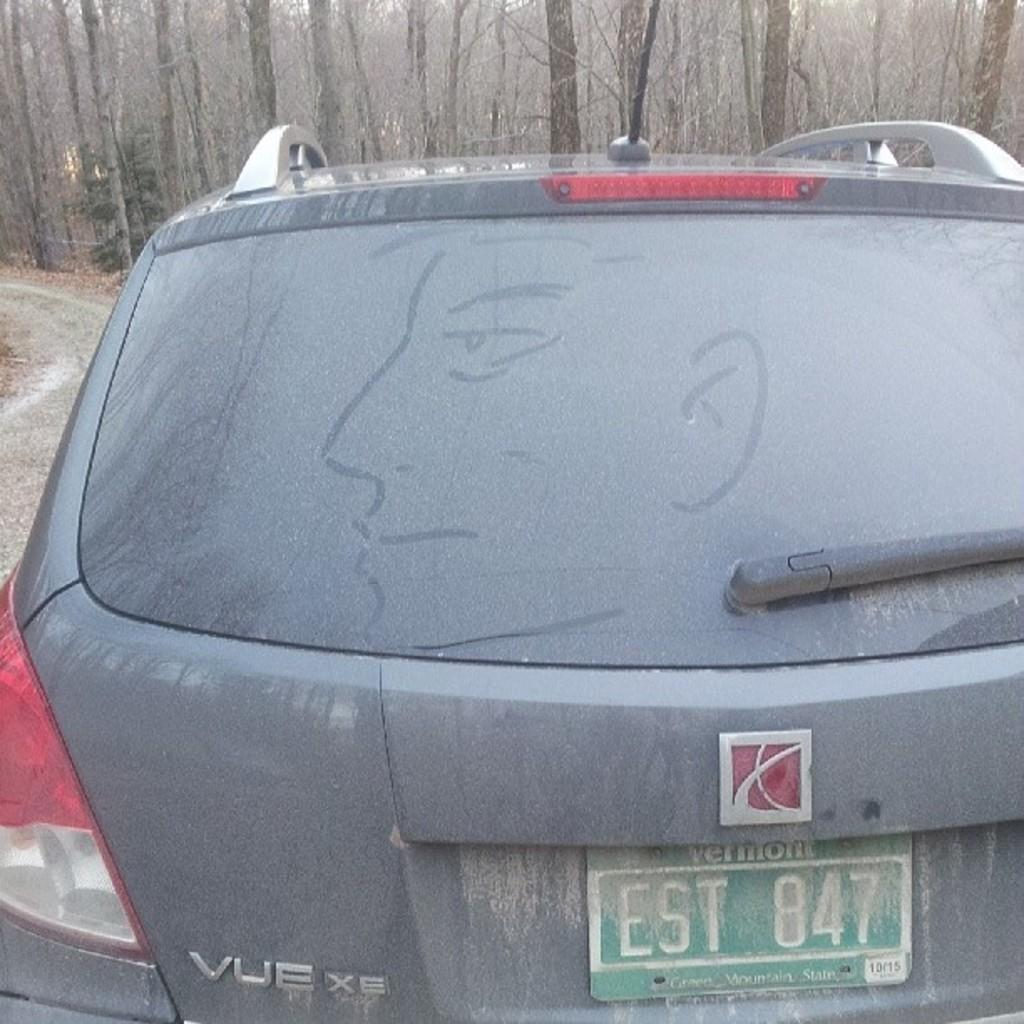What is the main subject of the image? The main subject of the image is a car. Can you describe the car's appearance? The car is grey in color. Is there any specific detail about the car that can be seen in the image? Yes, the car has a visible number plate. What can be seen in the background of the image? There are many trees in the background of the image. How many yams are being transported by the car in the image? There are no yams visible in the image, and the car is not shown to be transporting any. Are there any bikes present in the image? There is no mention of bikes in the provided facts, and none can be seen in the image. 